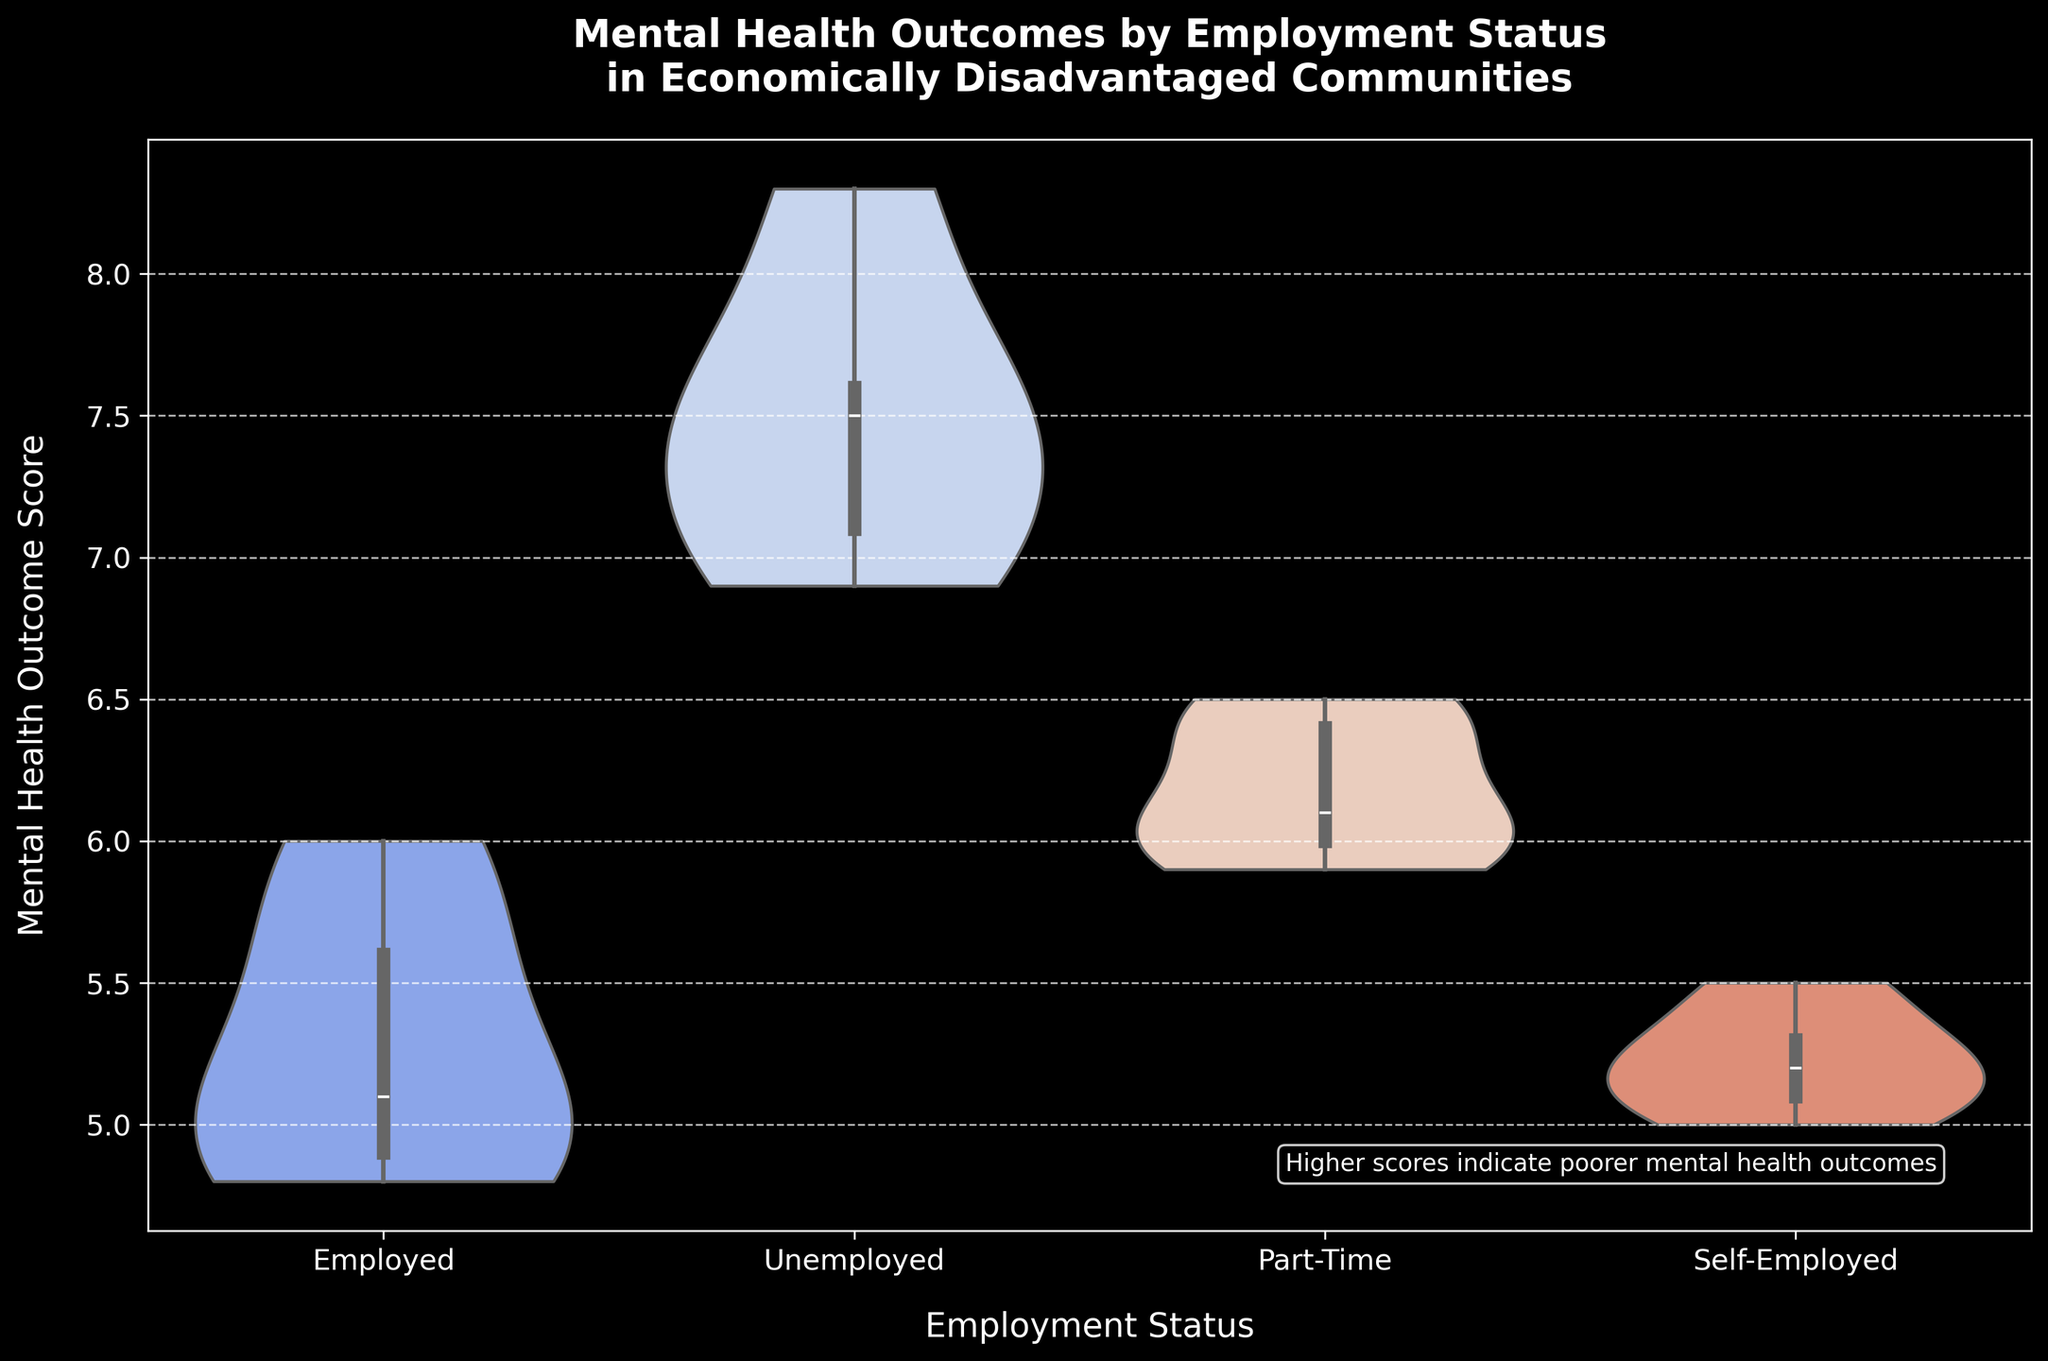What is the title of the figure? The title is written at the top of the figure and states the main subject of the plot, which is "Mental Health Outcomes by Employment Status in Economically Disadvantaged Communities".
Answer: Mental Health Outcomes by Employment Status in Economically Disadvantaged Communities What is the employment status with the highest median mental health outcome? The median mental health outcome is shown by the horizontal line inside each violin plot. By observing these lines, the employment status with the highest median mental health outcome is Unemployed.
Answer: Unemployed Which employment status has the narrowest range of mental health outcomes? The narrowest range can be identified by comparing the widths of the violin plots. The Self-Employed group has the narrowest range, as its plot appears the least stretched.
Answer: Self-Employed How does the distribution of mental health outcomes for part-time employment compare to full-time employment? The part-time employment group has a wider distribution with values spreading more distinctly between 5.9 and 6.5, while the employed group has a narrower range with most values centering close to its median. This suggests more variability in mental health outcomes among part-time workers.
Answer: Part-time has a wider distribution What is the general trend observed between employment status and mental health outcomes? By examining the positions and shapes of the violin plots, it's observable that employed and self-employed groups have better (lower) mental health outcomes, while unemployed individuals tend to have worse (higher) outcomes. Part-time workers fall in-between.
Answer: Unemployed have worse outcomes, employed have better What is the interquartile range (IQR) of the mental health outcomes for the Self-Employed? The interquartile range can be determined by looking at the box inside the violin plot of the Self-Employed category. The IQR is the difference between the third quartile and the first quartile which approximately ranges from 5.1 to 5.3.
Answer: 0.2 Are there any employment statuses with outliers in mental health outcomes? Outliers are typically shown as points outside the main body of the violin plot. In this figure, none of the violin plots show explicit outliers, indicating that all values lie within the observed distributions.
Answer: No Which employment status has the lowest minimum mental health outcome and what is that value? The minimum value is located at the bottom of the violin plot. The Employed status has the lowest minimum mental health outcome, around 4.8.
Answer: Employed, 4.8 